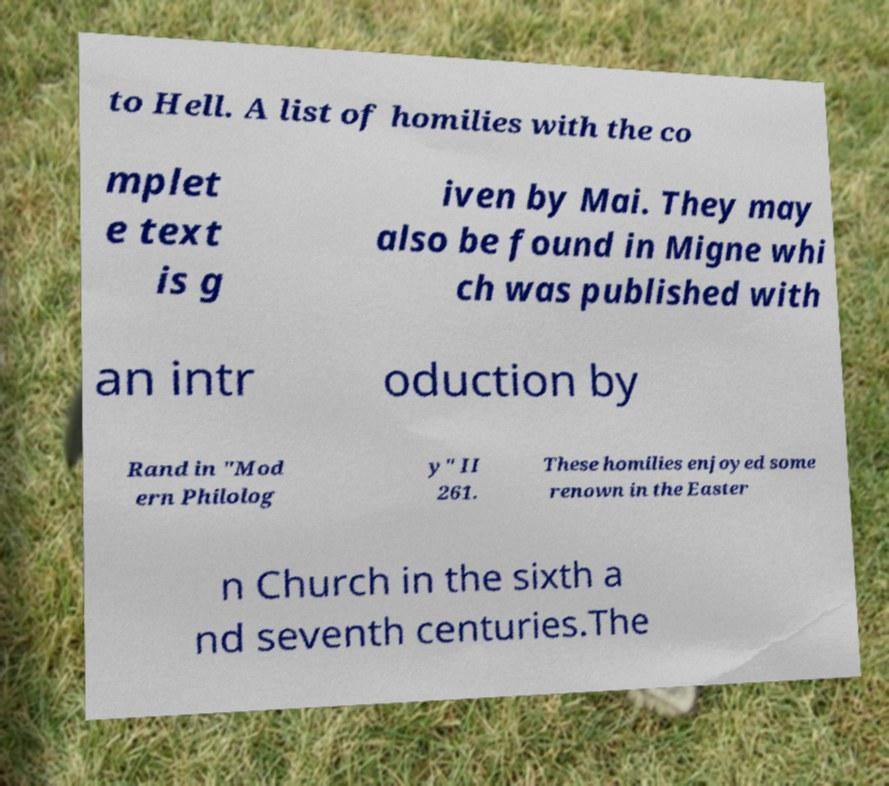Can you read and provide the text displayed in the image?This photo seems to have some interesting text. Can you extract and type it out for me? to Hell. A list of homilies with the co mplet e text is g iven by Mai. They may also be found in Migne whi ch was published with an intr oduction by Rand in "Mod ern Philolog y" II 261. These homilies enjoyed some renown in the Easter n Church in the sixth a nd seventh centuries.The 